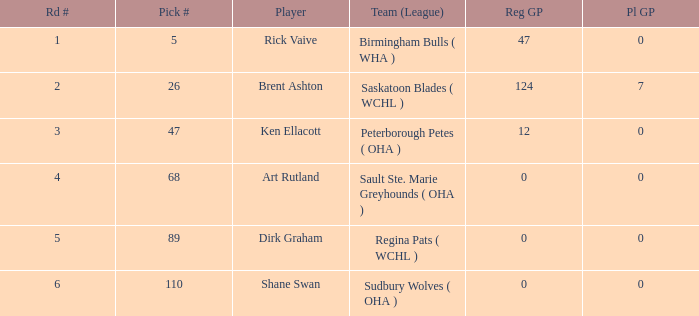How many typical gp for rick vaive in the opening round? None. 